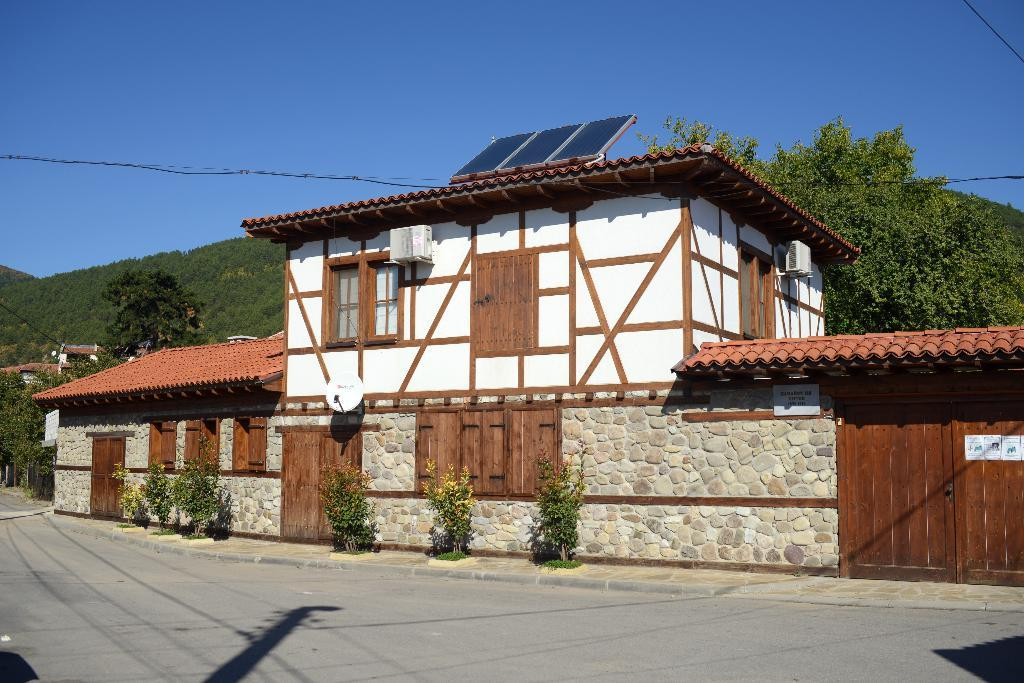What type of structure is visible in the image? There is a building in the image. What other natural elements can be seen in the image? There are plants, trees, and the sky visible in the image. What man-made feature is present in the image? There is a road in the image. What type of energy-efficient technology is featured in the image? Solar panels are present in the image. Can you describe the objects visible in the image? There are objects in the image, but their specific nature is not mentioned in the provided facts. How does the wilderness compare to the building in the image? There is no mention of wilderness in the image, so it cannot be compared to the building. What is located in the middle of the image? The provided facts do not specify any particular object or subject being in the middle of the image. 